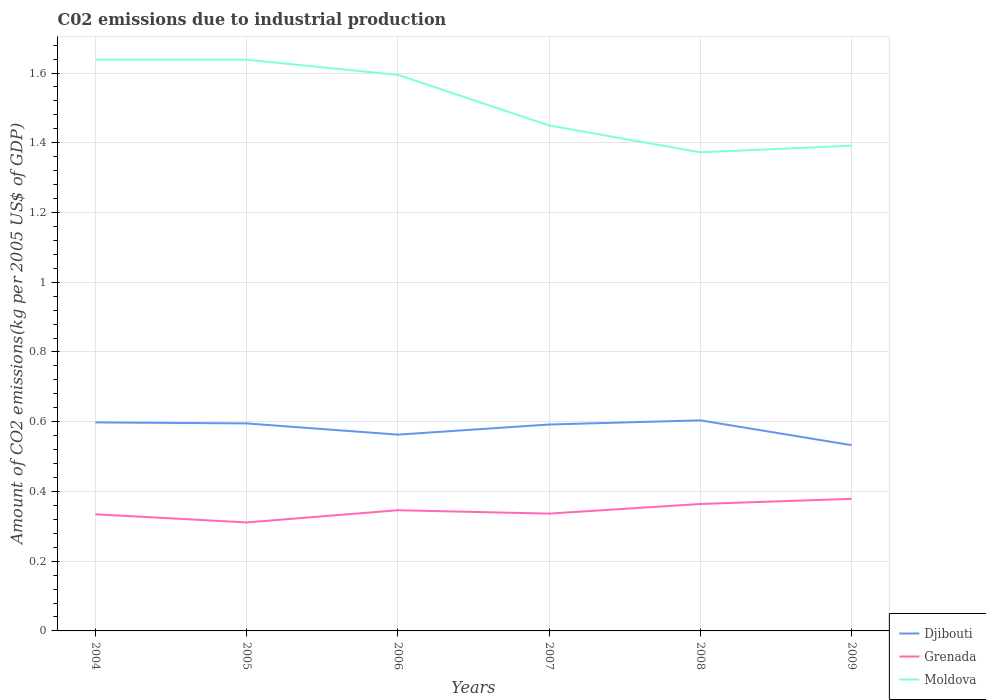How many different coloured lines are there?
Provide a succinct answer. 3. Does the line corresponding to Grenada intersect with the line corresponding to Moldova?
Provide a short and direct response. No. Across all years, what is the maximum amount of CO2 emitted due to industrial production in Djibouti?
Keep it short and to the point. 0.53. In which year was the amount of CO2 emitted due to industrial production in Moldova maximum?
Offer a terse response. 2008. What is the total amount of CO2 emitted due to industrial production in Moldova in the graph?
Offer a terse response. -0.02. What is the difference between the highest and the second highest amount of CO2 emitted due to industrial production in Grenada?
Your response must be concise. 0.07. Is the amount of CO2 emitted due to industrial production in Djibouti strictly greater than the amount of CO2 emitted due to industrial production in Grenada over the years?
Keep it short and to the point. No. How many lines are there?
Your answer should be very brief. 3. How many years are there in the graph?
Offer a very short reply. 6. What is the difference between two consecutive major ticks on the Y-axis?
Give a very brief answer. 0.2. Does the graph contain any zero values?
Your answer should be compact. No. Where does the legend appear in the graph?
Provide a short and direct response. Bottom right. How are the legend labels stacked?
Give a very brief answer. Vertical. What is the title of the graph?
Your response must be concise. C02 emissions due to industrial production. What is the label or title of the X-axis?
Keep it short and to the point. Years. What is the label or title of the Y-axis?
Your response must be concise. Amount of CO2 emissions(kg per 2005 US$ of GDP). What is the Amount of CO2 emissions(kg per 2005 US$ of GDP) of Djibouti in 2004?
Your answer should be very brief. 0.6. What is the Amount of CO2 emissions(kg per 2005 US$ of GDP) of Grenada in 2004?
Make the answer very short. 0.33. What is the Amount of CO2 emissions(kg per 2005 US$ of GDP) of Moldova in 2004?
Offer a very short reply. 1.64. What is the Amount of CO2 emissions(kg per 2005 US$ of GDP) of Djibouti in 2005?
Offer a very short reply. 0.6. What is the Amount of CO2 emissions(kg per 2005 US$ of GDP) of Grenada in 2005?
Your response must be concise. 0.31. What is the Amount of CO2 emissions(kg per 2005 US$ of GDP) in Moldova in 2005?
Provide a short and direct response. 1.64. What is the Amount of CO2 emissions(kg per 2005 US$ of GDP) in Djibouti in 2006?
Give a very brief answer. 0.56. What is the Amount of CO2 emissions(kg per 2005 US$ of GDP) in Grenada in 2006?
Your answer should be very brief. 0.35. What is the Amount of CO2 emissions(kg per 2005 US$ of GDP) of Moldova in 2006?
Your answer should be compact. 1.59. What is the Amount of CO2 emissions(kg per 2005 US$ of GDP) of Djibouti in 2007?
Your answer should be very brief. 0.59. What is the Amount of CO2 emissions(kg per 2005 US$ of GDP) in Grenada in 2007?
Keep it short and to the point. 0.34. What is the Amount of CO2 emissions(kg per 2005 US$ of GDP) of Moldova in 2007?
Give a very brief answer. 1.45. What is the Amount of CO2 emissions(kg per 2005 US$ of GDP) of Djibouti in 2008?
Offer a very short reply. 0.6. What is the Amount of CO2 emissions(kg per 2005 US$ of GDP) in Grenada in 2008?
Ensure brevity in your answer.  0.36. What is the Amount of CO2 emissions(kg per 2005 US$ of GDP) of Moldova in 2008?
Offer a terse response. 1.37. What is the Amount of CO2 emissions(kg per 2005 US$ of GDP) in Djibouti in 2009?
Ensure brevity in your answer.  0.53. What is the Amount of CO2 emissions(kg per 2005 US$ of GDP) in Grenada in 2009?
Make the answer very short. 0.38. What is the Amount of CO2 emissions(kg per 2005 US$ of GDP) in Moldova in 2009?
Provide a succinct answer. 1.39. Across all years, what is the maximum Amount of CO2 emissions(kg per 2005 US$ of GDP) of Djibouti?
Your answer should be very brief. 0.6. Across all years, what is the maximum Amount of CO2 emissions(kg per 2005 US$ of GDP) of Grenada?
Provide a short and direct response. 0.38. Across all years, what is the maximum Amount of CO2 emissions(kg per 2005 US$ of GDP) of Moldova?
Keep it short and to the point. 1.64. Across all years, what is the minimum Amount of CO2 emissions(kg per 2005 US$ of GDP) of Djibouti?
Your answer should be very brief. 0.53. Across all years, what is the minimum Amount of CO2 emissions(kg per 2005 US$ of GDP) of Grenada?
Provide a succinct answer. 0.31. Across all years, what is the minimum Amount of CO2 emissions(kg per 2005 US$ of GDP) of Moldova?
Provide a short and direct response. 1.37. What is the total Amount of CO2 emissions(kg per 2005 US$ of GDP) of Djibouti in the graph?
Your answer should be very brief. 3.48. What is the total Amount of CO2 emissions(kg per 2005 US$ of GDP) of Grenada in the graph?
Provide a short and direct response. 2.07. What is the total Amount of CO2 emissions(kg per 2005 US$ of GDP) in Moldova in the graph?
Keep it short and to the point. 9.09. What is the difference between the Amount of CO2 emissions(kg per 2005 US$ of GDP) in Djibouti in 2004 and that in 2005?
Make the answer very short. 0. What is the difference between the Amount of CO2 emissions(kg per 2005 US$ of GDP) in Grenada in 2004 and that in 2005?
Provide a succinct answer. 0.02. What is the difference between the Amount of CO2 emissions(kg per 2005 US$ of GDP) of Djibouti in 2004 and that in 2006?
Your answer should be compact. 0.04. What is the difference between the Amount of CO2 emissions(kg per 2005 US$ of GDP) of Grenada in 2004 and that in 2006?
Your answer should be very brief. -0.01. What is the difference between the Amount of CO2 emissions(kg per 2005 US$ of GDP) in Moldova in 2004 and that in 2006?
Make the answer very short. 0.04. What is the difference between the Amount of CO2 emissions(kg per 2005 US$ of GDP) of Djibouti in 2004 and that in 2007?
Ensure brevity in your answer.  0.01. What is the difference between the Amount of CO2 emissions(kg per 2005 US$ of GDP) of Grenada in 2004 and that in 2007?
Ensure brevity in your answer.  -0. What is the difference between the Amount of CO2 emissions(kg per 2005 US$ of GDP) in Moldova in 2004 and that in 2007?
Make the answer very short. 0.19. What is the difference between the Amount of CO2 emissions(kg per 2005 US$ of GDP) in Djibouti in 2004 and that in 2008?
Your answer should be compact. -0.01. What is the difference between the Amount of CO2 emissions(kg per 2005 US$ of GDP) of Grenada in 2004 and that in 2008?
Provide a succinct answer. -0.03. What is the difference between the Amount of CO2 emissions(kg per 2005 US$ of GDP) in Moldova in 2004 and that in 2008?
Give a very brief answer. 0.27. What is the difference between the Amount of CO2 emissions(kg per 2005 US$ of GDP) of Djibouti in 2004 and that in 2009?
Offer a terse response. 0.07. What is the difference between the Amount of CO2 emissions(kg per 2005 US$ of GDP) of Grenada in 2004 and that in 2009?
Your response must be concise. -0.04. What is the difference between the Amount of CO2 emissions(kg per 2005 US$ of GDP) in Moldova in 2004 and that in 2009?
Ensure brevity in your answer.  0.25. What is the difference between the Amount of CO2 emissions(kg per 2005 US$ of GDP) in Djibouti in 2005 and that in 2006?
Offer a terse response. 0.03. What is the difference between the Amount of CO2 emissions(kg per 2005 US$ of GDP) of Grenada in 2005 and that in 2006?
Your answer should be compact. -0.04. What is the difference between the Amount of CO2 emissions(kg per 2005 US$ of GDP) in Moldova in 2005 and that in 2006?
Make the answer very short. 0.04. What is the difference between the Amount of CO2 emissions(kg per 2005 US$ of GDP) of Djibouti in 2005 and that in 2007?
Offer a very short reply. 0. What is the difference between the Amount of CO2 emissions(kg per 2005 US$ of GDP) of Grenada in 2005 and that in 2007?
Provide a succinct answer. -0.03. What is the difference between the Amount of CO2 emissions(kg per 2005 US$ of GDP) in Moldova in 2005 and that in 2007?
Your answer should be compact. 0.19. What is the difference between the Amount of CO2 emissions(kg per 2005 US$ of GDP) of Djibouti in 2005 and that in 2008?
Ensure brevity in your answer.  -0.01. What is the difference between the Amount of CO2 emissions(kg per 2005 US$ of GDP) in Grenada in 2005 and that in 2008?
Offer a terse response. -0.05. What is the difference between the Amount of CO2 emissions(kg per 2005 US$ of GDP) in Moldova in 2005 and that in 2008?
Keep it short and to the point. 0.27. What is the difference between the Amount of CO2 emissions(kg per 2005 US$ of GDP) in Djibouti in 2005 and that in 2009?
Give a very brief answer. 0.06. What is the difference between the Amount of CO2 emissions(kg per 2005 US$ of GDP) in Grenada in 2005 and that in 2009?
Your response must be concise. -0.07. What is the difference between the Amount of CO2 emissions(kg per 2005 US$ of GDP) in Moldova in 2005 and that in 2009?
Give a very brief answer. 0.25. What is the difference between the Amount of CO2 emissions(kg per 2005 US$ of GDP) in Djibouti in 2006 and that in 2007?
Offer a terse response. -0.03. What is the difference between the Amount of CO2 emissions(kg per 2005 US$ of GDP) of Grenada in 2006 and that in 2007?
Your answer should be very brief. 0.01. What is the difference between the Amount of CO2 emissions(kg per 2005 US$ of GDP) of Moldova in 2006 and that in 2007?
Ensure brevity in your answer.  0.15. What is the difference between the Amount of CO2 emissions(kg per 2005 US$ of GDP) of Djibouti in 2006 and that in 2008?
Give a very brief answer. -0.04. What is the difference between the Amount of CO2 emissions(kg per 2005 US$ of GDP) in Grenada in 2006 and that in 2008?
Offer a terse response. -0.02. What is the difference between the Amount of CO2 emissions(kg per 2005 US$ of GDP) in Moldova in 2006 and that in 2008?
Offer a terse response. 0.22. What is the difference between the Amount of CO2 emissions(kg per 2005 US$ of GDP) of Djibouti in 2006 and that in 2009?
Your response must be concise. 0.03. What is the difference between the Amount of CO2 emissions(kg per 2005 US$ of GDP) of Grenada in 2006 and that in 2009?
Your response must be concise. -0.03. What is the difference between the Amount of CO2 emissions(kg per 2005 US$ of GDP) in Moldova in 2006 and that in 2009?
Make the answer very short. 0.2. What is the difference between the Amount of CO2 emissions(kg per 2005 US$ of GDP) of Djibouti in 2007 and that in 2008?
Offer a very short reply. -0.01. What is the difference between the Amount of CO2 emissions(kg per 2005 US$ of GDP) in Grenada in 2007 and that in 2008?
Give a very brief answer. -0.03. What is the difference between the Amount of CO2 emissions(kg per 2005 US$ of GDP) in Moldova in 2007 and that in 2008?
Provide a short and direct response. 0.08. What is the difference between the Amount of CO2 emissions(kg per 2005 US$ of GDP) of Djibouti in 2007 and that in 2009?
Keep it short and to the point. 0.06. What is the difference between the Amount of CO2 emissions(kg per 2005 US$ of GDP) in Grenada in 2007 and that in 2009?
Provide a short and direct response. -0.04. What is the difference between the Amount of CO2 emissions(kg per 2005 US$ of GDP) in Moldova in 2007 and that in 2009?
Offer a terse response. 0.06. What is the difference between the Amount of CO2 emissions(kg per 2005 US$ of GDP) of Djibouti in 2008 and that in 2009?
Provide a short and direct response. 0.07. What is the difference between the Amount of CO2 emissions(kg per 2005 US$ of GDP) in Grenada in 2008 and that in 2009?
Give a very brief answer. -0.01. What is the difference between the Amount of CO2 emissions(kg per 2005 US$ of GDP) of Moldova in 2008 and that in 2009?
Give a very brief answer. -0.02. What is the difference between the Amount of CO2 emissions(kg per 2005 US$ of GDP) of Djibouti in 2004 and the Amount of CO2 emissions(kg per 2005 US$ of GDP) of Grenada in 2005?
Your response must be concise. 0.29. What is the difference between the Amount of CO2 emissions(kg per 2005 US$ of GDP) in Djibouti in 2004 and the Amount of CO2 emissions(kg per 2005 US$ of GDP) in Moldova in 2005?
Provide a short and direct response. -1.04. What is the difference between the Amount of CO2 emissions(kg per 2005 US$ of GDP) of Grenada in 2004 and the Amount of CO2 emissions(kg per 2005 US$ of GDP) of Moldova in 2005?
Offer a very short reply. -1.3. What is the difference between the Amount of CO2 emissions(kg per 2005 US$ of GDP) of Djibouti in 2004 and the Amount of CO2 emissions(kg per 2005 US$ of GDP) of Grenada in 2006?
Your response must be concise. 0.25. What is the difference between the Amount of CO2 emissions(kg per 2005 US$ of GDP) in Djibouti in 2004 and the Amount of CO2 emissions(kg per 2005 US$ of GDP) in Moldova in 2006?
Ensure brevity in your answer.  -1. What is the difference between the Amount of CO2 emissions(kg per 2005 US$ of GDP) in Grenada in 2004 and the Amount of CO2 emissions(kg per 2005 US$ of GDP) in Moldova in 2006?
Provide a succinct answer. -1.26. What is the difference between the Amount of CO2 emissions(kg per 2005 US$ of GDP) in Djibouti in 2004 and the Amount of CO2 emissions(kg per 2005 US$ of GDP) in Grenada in 2007?
Make the answer very short. 0.26. What is the difference between the Amount of CO2 emissions(kg per 2005 US$ of GDP) in Djibouti in 2004 and the Amount of CO2 emissions(kg per 2005 US$ of GDP) in Moldova in 2007?
Offer a terse response. -0.85. What is the difference between the Amount of CO2 emissions(kg per 2005 US$ of GDP) in Grenada in 2004 and the Amount of CO2 emissions(kg per 2005 US$ of GDP) in Moldova in 2007?
Give a very brief answer. -1.12. What is the difference between the Amount of CO2 emissions(kg per 2005 US$ of GDP) in Djibouti in 2004 and the Amount of CO2 emissions(kg per 2005 US$ of GDP) in Grenada in 2008?
Your answer should be compact. 0.23. What is the difference between the Amount of CO2 emissions(kg per 2005 US$ of GDP) in Djibouti in 2004 and the Amount of CO2 emissions(kg per 2005 US$ of GDP) in Moldova in 2008?
Your response must be concise. -0.77. What is the difference between the Amount of CO2 emissions(kg per 2005 US$ of GDP) in Grenada in 2004 and the Amount of CO2 emissions(kg per 2005 US$ of GDP) in Moldova in 2008?
Offer a terse response. -1.04. What is the difference between the Amount of CO2 emissions(kg per 2005 US$ of GDP) in Djibouti in 2004 and the Amount of CO2 emissions(kg per 2005 US$ of GDP) in Grenada in 2009?
Offer a very short reply. 0.22. What is the difference between the Amount of CO2 emissions(kg per 2005 US$ of GDP) of Djibouti in 2004 and the Amount of CO2 emissions(kg per 2005 US$ of GDP) of Moldova in 2009?
Provide a short and direct response. -0.79. What is the difference between the Amount of CO2 emissions(kg per 2005 US$ of GDP) of Grenada in 2004 and the Amount of CO2 emissions(kg per 2005 US$ of GDP) of Moldova in 2009?
Provide a short and direct response. -1.06. What is the difference between the Amount of CO2 emissions(kg per 2005 US$ of GDP) in Djibouti in 2005 and the Amount of CO2 emissions(kg per 2005 US$ of GDP) in Grenada in 2006?
Your answer should be very brief. 0.25. What is the difference between the Amount of CO2 emissions(kg per 2005 US$ of GDP) of Djibouti in 2005 and the Amount of CO2 emissions(kg per 2005 US$ of GDP) of Moldova in 2006?
Your answer should be compact. -1. What is the difference between the Amount of CO2 emissions(kg per 2005 US$ of GDP) of Grenada in 2005 and the Amount of CO2 emissions(kg per 2005 US$ of GDP) of Moldova in 2006?
Ensure brevity in your answer.  -1.28. What is the difference between the Amount of CO2 emissions(kg per 2005 US$ of GDP) in Djibouti in 2005 and the Amount of CO2 emissions(kg per 2005 US$ of GDP) in Grenada in 2007?
Your response must be concise. 0.26. What is the difference between the Amount of CO2 emissions(kg per 2005 US$ of GDP) of Djibouti in 2005 and the Amount of CO2 emissions(kg per 2005 US$ of GDP) of Moldova in 2007?
Give a very brief answer. -0.85. What is the difference between the Amount of CO2 emissions(kg per 2005 US$ of GDP) of Grenada in 2005 and the Amount of CO2 emissions(kg per 2005 US$ of GDP) of Moldova in 2007?
Your answer should be very brief. -1.14. What is the difference between the Amount of CO2 emissions(kg per 2005 US$ of GDP) in Djibouti in 2005 and the Amount of CO2 emissions(kg per 2005 US$ of GDP) in Grenada in 2008?
Your answer should be very brief. 0.23. What is the difference between the Amount of CO2 emissions(kg per 2005 US$ of GDP) in Djibouti in 2005 and the Amount of CO2 emissions(kg per 2005 US$ of GDP) in Moldova in 2008?
Offer a very short reply. -0.78. What is the difference between the Amount of CO2 emissions(kg per 2005 US$ of GDP) in Grenada in 2005 and the Amount of CO2 emissions(kg per 2005 US$ of GDP) in Moldova in 2008?
Make the answer very short. -1.06. What is the difference between the Amount of CO2 emissions(kg per 2005 US$ of GDP) in Djibouti in 2005 and the Amount of CO2 emissions(kg per 2005 US$ of GDP) in Grenada in 2009?
Your answer should be very brief. 0.22. What is the difference between the Amount of CO2 emissions(kg per 2005 US$ of GDP) in Djibouti in 2005 and the Amount of CO2 emissions(kg per 2005 US$ of GDP) in Moldova in 2009?
Provide a succinct answer. -0.8. What is the difference between the Amount of CO2 emissions(kg per 2005 US$ of GDP) of Grenada in 2005 and the Amount of CO2 emissions(kg per 2005 US$ of GDP) of Moldova in 2009?
Ensure brevity in your answer.  -1.08. What is the difference between the Amount of CO2 emissions(kg per 2005 US$ of GDP) of Djibouti in 2006 and the Amount of CO2 emissions(kg per 2005 US$ of GDP) of Grenada in 2007?
Offer a very short reply. 0.23. What is the difference between the Amount of CO2 emissions(kg per 2005 US$ of GDP) of Djibouti in 2006 and the Amount of CO2 emissions(kg per 2005 US$ of GDP) of Moldova in 2007?
Your answer should be compact. -0.89. What is the difference between the Amount of CO2 emissions(kg per 2005 US$ of GDP) in Grenada in 2006 and the Amount of CO2 emissions(kg per 2005 US$ of GDP) in Moldova in 2007?
Your response must be concise. -1.1. What is the difference between the Amount of CO2 emissions(kg per 2005 US$ of GDP) of Djibouti in 2006 and the Amount of CO2 emissions(kg per 2005 US$ of GDP) of Grenada in 2008?
Provide a succinct answer. 0.2. What is the difference between the Amount of CO2 emissions(kg per 2005 US$ of GDP) in Djibouti in 2006 and the Amount of CO2 emissions(kg per 2005 US$ of GDP) in Moldova in 2008?
Ensure brevity in your answer.  -0.81. What is the difference between the Amount of CO2 emissions(kg per 2005 US$ of GDP) in Grenada in 2006 and the Amount of CO2 emissions(kg per 2005 US$ of GDP) in Moldova in 2008?
Make the answer very short. -1.03. What is the difference between the Amount of CO2 emissions(kg per 2005 US$ of GDP) in Djibouti in 2006 and the Amount of CO2 emissions(kg per 2005 US$ of GDP) in Grenada in 2009?
Offer a terse response. 0.18. What is the difference between the Amount of CO2 emissions(kg per 2005 US$ of GDP) of Djibouti in 2006 and the Amount of CO2 emissions(kg per 2005 US$ of GDP) of Moldova in 2009?
Make the answer very short. -0.83. What is the difference between the Amount of CO2 emissions(kg per 2005 US$ of GDP) in Grenada in 2006 and the Amount of CO2 emissions(kg per 2005 US$ of GDP) in Moldova in 2009?
Your answer should be compact. -1.05. What is the difference between the Amount of CO2 emissions(kg per 2005 US$ of GDP) in Djibouti in 2007 and the Amount of CO2 emissions(kg per 2005 US$ of GDP) in Grenada in 2008?
Make the answer very short. 0.23. What is the difference between the Amount of CO2 emissions(kg per 2005 US$ of GDP) in Djibouti in 2007 and the Amount of CO2 emissions(kg per 2005 US$ of GDP) in Moldova in 2008?
Keep it short and to the point. -0.78. What is the difference between the Amount of CO2 emissions(kg per 2005 US$ of GDP) in Grenada in 2007 and the Amount of CO2 emissions(kg per 2005 US$ of GDP) in Moldova in 2008?
Your answer should be very brief. -1.04. What is the difference between the Amount of CO2 emissions(kg per 2005 US$ of GDP) in Djibouti in 2007 and the Amount of CO2 emissions(kg per 2005 US$ of GDP) in Grenada in 2009?
Provide a short and direct response. 0.21. What is the difference between the Amount of CO2 emissions(kg per 2005 US$ of GDP) of Djibouti in 2007 and the Amount of CO2 emissions(kg per 2005 US$ of GDP) of Moldova in 2009?
Make the answer very short. -0.8. What is the difference between the Amount of CO2 emissions(kg per 2005 US$ of GDP) of Grenada in 2007 and the Amount of CO2 emissions(kg per 2005 US$ of GDP) of Moldova in 2009?
Offer a very short reply. -1.06. What is the difference between the Amount of CO2 emissions(kg per 2005 US$ of GDP) in Djibouti in 2008 and the Amount of CO2 emissions(kg per 2005 US$ of GDP) in Grenada in 2009?
Give a very brief answer. 0.23. What is the difference between the Amount of CO2 emissions(kg per 2005 US$ of GDP) in Djibouti in 2008 and the Amount of CO2 emissions(kg per 2005 US$ of GDP) in Moldova in 2009?
Your answer should be very brief. -0.79. What is the difference between the Amount of CO2 emissions(kg per 2005 US$ of GDP) of Grenada in 2008 and the Amount of CO2 emissions(kg per 2005 US$ of GDP) of Moldova in 2009?
Ensure brevity in your answer.  -1.03. What is the average Amount of CO2 emissions(kg per 2005 US$ of GDP) in Djibouti per year?
Ensure brevity in your answer.  0.58. What is the average Amount of CO2 emissions(kg per 2005 US$ of GDP) of Grenada per year?
Your answer should be compact. 0.35. What is the average Amount of CO2 emissions(kg per 2005 US$ of GDP) of Moldova per year?
Ensure brevity in your answer.  1.51. In the year 2004, what is the difference between the Amount of CO2 emissions(kg per 2005 US$ of GDP) in Djibouti and Amount of CO2 emissions(kg per 2005 US$ of GDP) in Grenada?
Offer a very short reply. 0.26. In the year 2004, what is the difference between the Amount of CO2 emissions(kg per 2005 US$ of GDP) of Djibouti and Amount of CO2 emissions(kg per 2005 US$ of GDP) of Moldova?
Make the answer very short. -1.04. In the year 2004, what is the difference between the Amount of CO2 emissions(kg per 2005 US$ of GDP) of Grenada and Amount of CO2 emissions(kg per 2005 US$ of GDP) of Moldova?
Give a very brief answer. -1.3. In the year 2005, what is the difference between the Amount of CO2 emissions(kg per 2005 US$ of GDP) of Djibouti and Amount of CO2 emissions(kg per 2005 US$ of GDP) of Grenada?
Offer a very short reply. 0.28. In the year 2005, what is the difference between the Amount of CO2 emissions(kg per 2005 US$ of GDP) in Djibouti and Amount of CO2 emissions(kg per 2005 US$ of GDP) in Moldova?
Provide a succinct answer. -1.04. In the year 2005, what is the difference between the Amount of CO2 emissions(kg per 2005 US$ of GDP) of Grenada and Amount of CO2 emissions(kg per 2005 US$ of GDP) of Moldova?
Ensure brevity in your answer.  -1.33. In the year 2006, what is the difference between the Amount of CO2 emissions(kg per 2005 US$ of GDP) of Djibouti and Amount of CO2 emissions(kg per 2005 US$ of GDP) of Grenada?
Offer a very short reply. 0.22. In the year 2006, what is the difference between the Amount of CO2 emissions(kg per 2005 US$ of GDP) of Djibouti and Amount of CO2 emissions(kg per 2005 US$ of GDP) of Moldova?
Your answer should be compact. -1.03. In the year 2006, what is the difference between the Amount of CO2 emissions(kg per 2005 US$ of GDP) in Grenada and Amount of CO2 emissions(kg per 2005 US$ of GDP) in Moldova?
Your response must be concise. -1.25. In the year 2007, what is the difference between the Amount of CO2 emissions(kg per 2005 US$ of GDP) in Djibouti and Amount of CO2 emissions(kg per 2005 US$ of GDP) in Grenada?
Provide a succinct answer. 0.26. In the year 2007, what is the difference between the Amount of CO2 emissions(kg per 2005 US$ of GDP) in Djibouti and Amount of CO2 emissions(kg per 2005 US$ of GDP) in Moldova?
Offer a very short reply. -0.86. In the year 2007, what is the difference between the Amount of CO2 emissions(kg per 2005 US$ of GDP) in Grenada and Amount of CO2 emissions(kg per 2005 US$ of GDP) in Moldova?
Provide a short and direct response. -1.11. In the year 2008, what is the difference between the Amount of CO2 emissions(kg per 2005 US$ of GDP) in Djibouti and Amount of CO2 emissions(kg per 2005 US$ of GDP) in Grenada?
Offer a terse response. 0.24. In the year 2008, what is the difference between the Amount of CO2 emissions(kg per 2005 US$ of GDP) of Djibouti and Amount of CO2 emissions(kg per 2005 US$ of GDP) of Moldova?
Offer a terse response. -0.77. In the year 2008, what is the difference between the Amount of CO2 emissions(kg per 2005 US$ of GDP) in Grenada and Amount of CO2 emissions(kg per 2005 US$ of GDP) in Moldova?
Provide a succinct answer. -1.01. In the year 2009, what is the difference between the Amount of CO2 emissions(kg per 2005 US$ of GDP) of Djibouti and Amount of CO2 emissions(kg per 2005 US$ of GDP) of Grenada?
Your answer should be very brief. 0.15. In the year 2009, what is the difference between the Amount of CO2 emissions(kg per 2005 US$ of GDP) of Djibouti and Amount of CO2 emissions(kg per 2005 US$ of GDP) of Moldova?
Offer a very short reply. -0.86. In the year 2009, what is the difference between the Amount of CO2 emissions(kg per 2005 US$ of GDP) of Grenada and Amount of CO2 emissions(kg per 2005 US$ of GDP) of Moldova?
Your response must be concise. -1.01. What is the ratio of the Amount of CO2 emissions(kg per 2005 US$ of GDP) of Djibouti in 2004 to that in 2005?
Ensure brevity in your answer.  1. What is the ratio of the Amount of CO2 emissions(kg per 2005 US$ of GDP) in Grenada in 2004 to that in 2005?
Keep it short and to the point. 1.08. What is the ratio of the Amount of CO2 emissions(kg per 2005 US$ of GDP) in Moldova in 2004 to that in 2005?
Your response must be concise. 1. What is the ratio of the Amount of CO2 emissions(kg per 2005 US$ of GDP) in Djibouti in 2004 to that in 2006?
Give a very brief answer. 1.06. What is the ratio of the Amount of CO2 emissions(kg per 2005 US$ of GDP) in Grenada in 2004 to that in 2006?
Offer a very short reply. 0.97. What is the ratio of the Amount of CO2 emissions(kg per 2005 US$ of GDP) in Moldova in 2004 to that in 2006?
Make the answer very short. 1.03. What is the ratio of the Amount of CO2 emissions(kg per 2005 US$ of GDP) in Djibouti in 2004 to that in 2007?
Make the answer very short. 1.01. What is the ratio of the Amount of CO2 emissions(kg per 2005 US$ of GDP) of Grenada in 2004 to that in 2007?
Your response must be concise. 0.99. What is the ratio of the Amount of CO2 emissions(kg per 2005 US$ of GDP) of Moldova in 2004 to that in 2007?
Make the answer very short. 1.13. What is the ratio of the Amount of CO2 emissions(kg per 2005 US$ of GDP) of Grenada in 2004 to that in 2008?
Keep it short and to the point. 0.92. What is the ratio of the Amount of CO2 emissions(kg per 2005 US$ of GDP) in Moldova in 2004 to that in 2008?
Your answer should be compact. 1.19. What is the ratio of the Amount of CO2 emissions(kg per 2005 US$ of GDP) in Djibouti in 2004 to that in 2009?
Provide a succinct answer. 1.12. What is the ratio of the Amount of CO2 emissions(kg per 2005 US$ of GDP) in Grenada in 2004 to that in 2009?
Give a very brief answer. 0.88. What is the ratio of the Amount of CO2 emissions(kg per 2005 US$ of GDP) in Moldova in 2004 to that in 2009?
Your answer should be compact. 1.18. What is the ratio of the Amount of CO2 emissions(kg per 2005 US$ of GDP) of Djibouti in 2005 to that in 2006?
Your answer should be very brief. 1.06. What is the ratio of the Amount of CO2 emissions(kg per 2005 US$ of GDP) in Grenada in 2005 to that in 2006?
Provide a succinct answer. 0.9. What is the ratio of the Amount of CO2 emissions(kg per 2005 US$ of GDP) of Moldova in 2005 to that in 2006?
Your answer should be compact. 1.03. What is the ratio of the Amount of CO2 emissions(kg per 2005 US$ of GDP) in Grenada in 2005 to that in 2007?
Ensure brevity in your answer.  0.92. What is the ratio of the Amount of CO2 emissions(kg per 2005 US$ of GDP) in Moldova in 2005 to that in 2007?
Your response must be concise. 1.13. What is the ratio of the Amount of CO2 emissions(kg per 2005 US$ of GDP) of Djibouti in 2005 to that in 2008?
Your answer should be very brief. 0.99. What is the ratio of the Amount of CO2 emissions(kg per 2005 US$ of GDP) of Grenada in 2005 to that in 2008?
Provide a succinct answer. 0.85. What is the ratio of the Amount of CO2 emissions(kg per 2005 US$ of GDP) in Moldova in 2005 to that in 2008?
Offer a terse response. 1.19. What is the ratio of the Amount of CO2 emissions(kg per 2005 US$ of GDP) of Djibouti in 2005 to that in 2009?
Your response must be concise. 1.12. What is the ratio of the Amount of CO2 emissions(kg per 2005 US$ of GDP) in Grenada in 2005 to that in 2009?
Offer a very short reply. 0.82. What is the ratio of the Amount of CO2 emissions(kg per 2005 US$ of GDP) in Moldova in 2005 to that in 2009?
Ensure brevity in your answer.  1.18. What is the ratio of the Amount of CO2 emissions(kg per 2005 US$ of GDP) of Djibouti in 2006 to that in 2007?
Your answer should be very brief. 0.95. What is the ratio of the Amount of CO2 emissions(kg per 2005 US$ of GDP) of Grenada in 2006 to that in 2007?
Give a very brief answer. 1.03. What is the ratio of the Amount of CO2 emissions(kg per 2005 US$ of GDP) in Moldova in 2006 to that in 2007?
Your answer should be very brief. 1.1. What is the ratio of the Amount of CO2 emissions(kg per 2005 US$ of GDP) in Djibouti in 2006 to that in 2008?
Provide a succinct answer. 0.93. What is the ratio of the Amount of CO2 emissions(kg per 2005 US$ of GDP) in Grenada in 2006 to that in 2008?
Your answer should be compact. 0.95. What is the ratio of the Amount of CO2 emissions(kg per 2005 US$ of GDP) of Moldova in 2006 to that in 2008?
Your response must be concise. 1.16. What is the ratio of the Amount of CO2 emissions(kg per 2005 US$ of GDP) in Djibouti in 2006 to that in 2009?
Give a very brief answer. 1.06. What is the ratio of the Amount of CO2 emissions(kg per 2005 US$ of GDP) in Grenada in 2006 to that in 2009?
Offer a terse response. 0.91. What is the ratio of the Amount of CO2 emissions(kg per 2005 US$ of GDP) of Moldova in 2006 to that in 2009?
Your response must be concise. 1.15. What is the ratio of the Amount of CO2 emissions(kg per 2005 US$ of GDP) of Djibouti in 2007 to that in 2008?
Your response must be concise. 0.98. What is the ratio of the Amount of CO2 emissions(kg per 2005 US$ of GDP) in Grenada in 2007 to that in 2008?
Provide a succinct answer. 0.92. What is the ratio of the Amount of CO2 emissions(kg per 2005 US$ of GDP) of Moldova in 2007 to that in 2008?
Give a very brief answer. 1.06. What is the ratio of the Amount of CO2 emissions(kg per 2005 US$ of GDP) of Djibouti in 2007 to that in 2009?
Ensure brevity in your answer.  1.11. What is the ratio of the Amount of CO2 emissions(kg per 2005 US$ of GDP) in Grenada in 2007 to that in 2009?
Offer a very short reply. 0.89. What is the ratio of the Amount of CO2 emissions(kg per 2005 US$ of GDP) of Moldova in 2007 to that in 2009?
Your response must be concise. 1.04. What is the ratio of the Amount of CO2 emissions(kg per 2005 US$ of GDP) in Djibouti in 2008 to that in 2009?
Your answer should be very brief. 1.13. What is the ratio of the Amount of CO2 emissions(kg per 2005 US$ of GDP) in Grenada in 2008 to that in 2009?
Keep it short and to the point. 0.96. What is the ratio of the Amount of CO2 emissions(kg per 2005 US$ of GDP) in Moldova in 2008 to that in 2009?
Make the answer very short. 0.99. What is the difference between the highest and the second highest Amount of CO2 emissions(kg per 2005 US$ of GDP) of Djibouti?
Offer a very short reply. 0.01. What is the difference between the highest and the second highest Amount of CO2 emissions(kg per 2005 US$ of GDP) in Grenada?
Ensure brevity in your answer.  0.01. What is the difference between the highest and the lowest Amount of CO2 emissions(kg per 2005 US$ of GDP) of Djibouti?
Provide a short and direct response. 0.07. What is the difference between the highest and the lowest Amount of CO2 emissions(kg per 2005 US$ of GDP) of Grenada?
Your answer should be compact. 0.07. What is the difference between the highest and the lowest Amount of CO2 emissions(kg per 2005 US$ of GDP) of Moldova?
Make the answer very short. 0.27. 